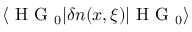Convert formula to latex. <formula><loc_0><loc_0><loc_500><loc_500>\langle H G _ { 0 } | \delta n ( x , \xi ) | H G _ { 0 } \rangle</formula> 